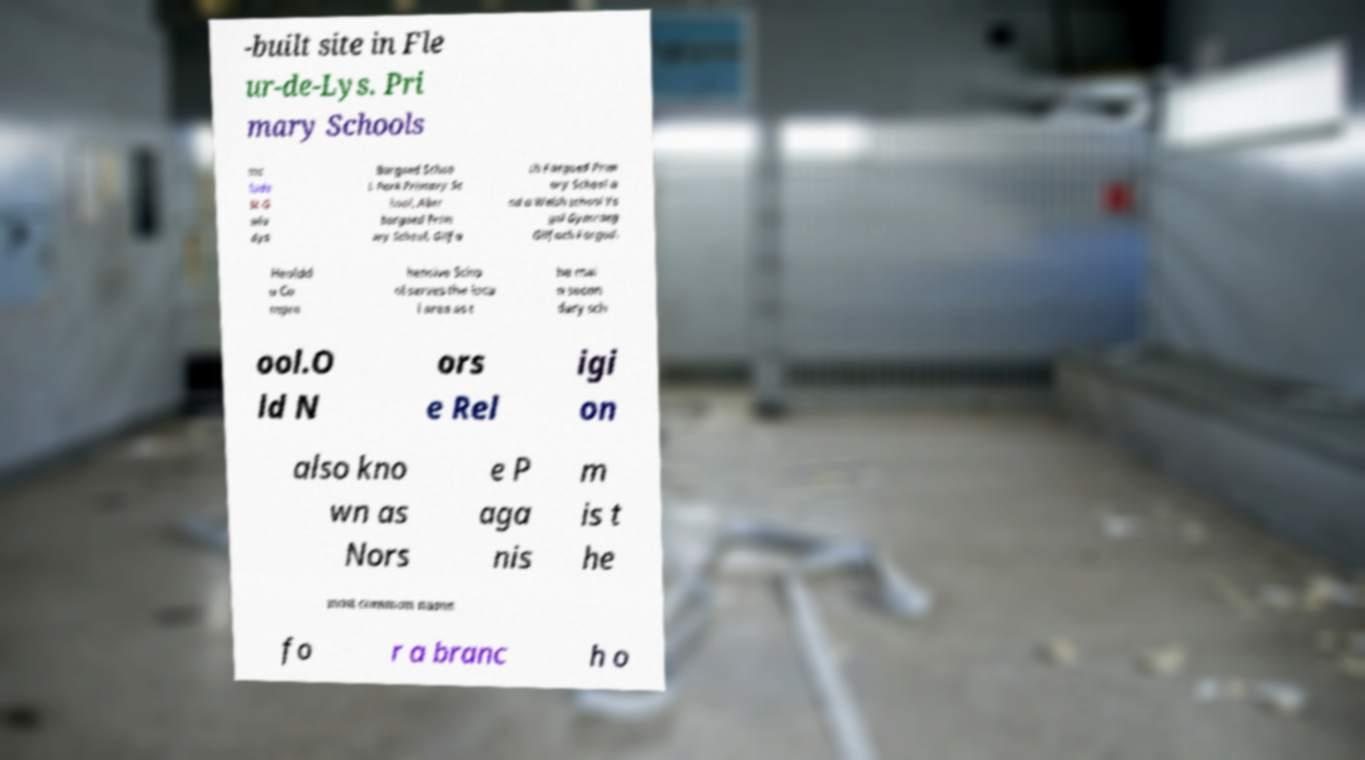I need the written content from this picture converted into text. Can you do that? -built site in Fle ur-de-Lys. Pri mary Schools inc lude St G wla dys Bargoed Schoo l, Park Primary Sc hool, Aber bargoed Prim ary School, Gilfa ch Fargoed Prim ary School a nd a Welsh school Ys gol Gymraeg Gilfach Fargod. Heoldd u Co mpre hensive Scho ol serves the loca l area as t he mai n secon dary sch ool.O ld N ors e Rel igi on also kno wn as Nors e P aga nis m is t he most common name fo r a branc h o 